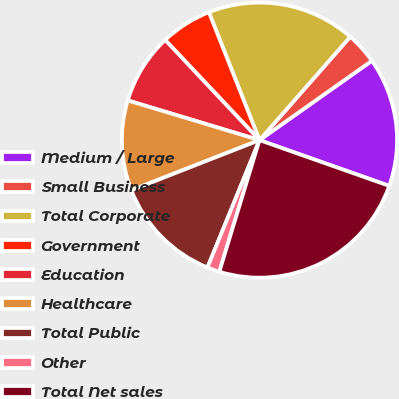Convert chart. <chart><loc_0><loc_0><loc_500><loc_500><pie_chart><fcel>Medium / Large<fcel>Small Business<fcel>Total Corporate<fcel>Government<fcel>Education<fcel>Healthcare<fcel>Total Public<fcel>Other<fcel>Total Net sales<nl><fcel>15.18%<fcel>3.75%<fcel>17.46%<fcel>6.03%<fcel>8.32%<fcel>10.6%<fcel>12.89%<fcel>1.46%<fcel>24.32%<nl></chart> 